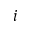<formula> <loc_0><loc_0><loc_500><loc_500>i</formula> 